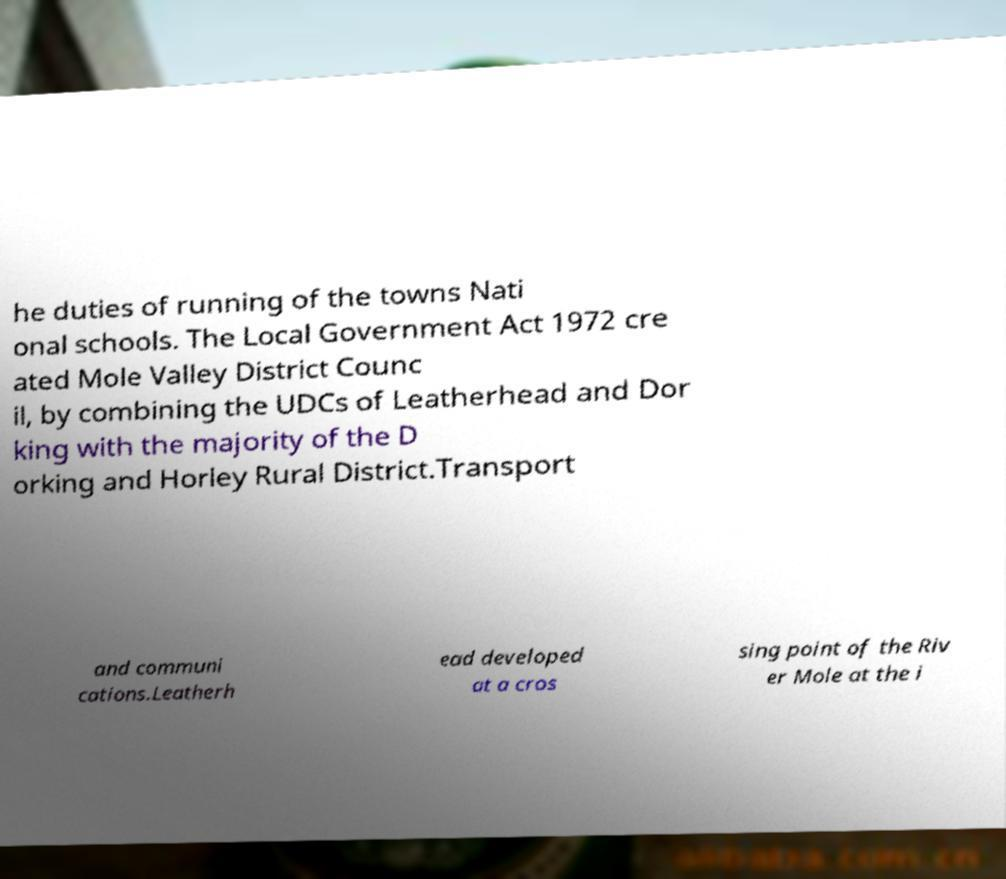There's text embedded in this image that I need extracted. Can you transcribe it verbatim? he duties of running of the towns Nati onal schools. The Local Government Act 1972 cre ated Mole Valley District Counc il, by combining the UDCs of Leatherhead and Dor king with the majority of the D orking and Horley Rural District.Transport and communi cations.Leatherh ead developed at a cros sing point of the Riv er Mole at the i 